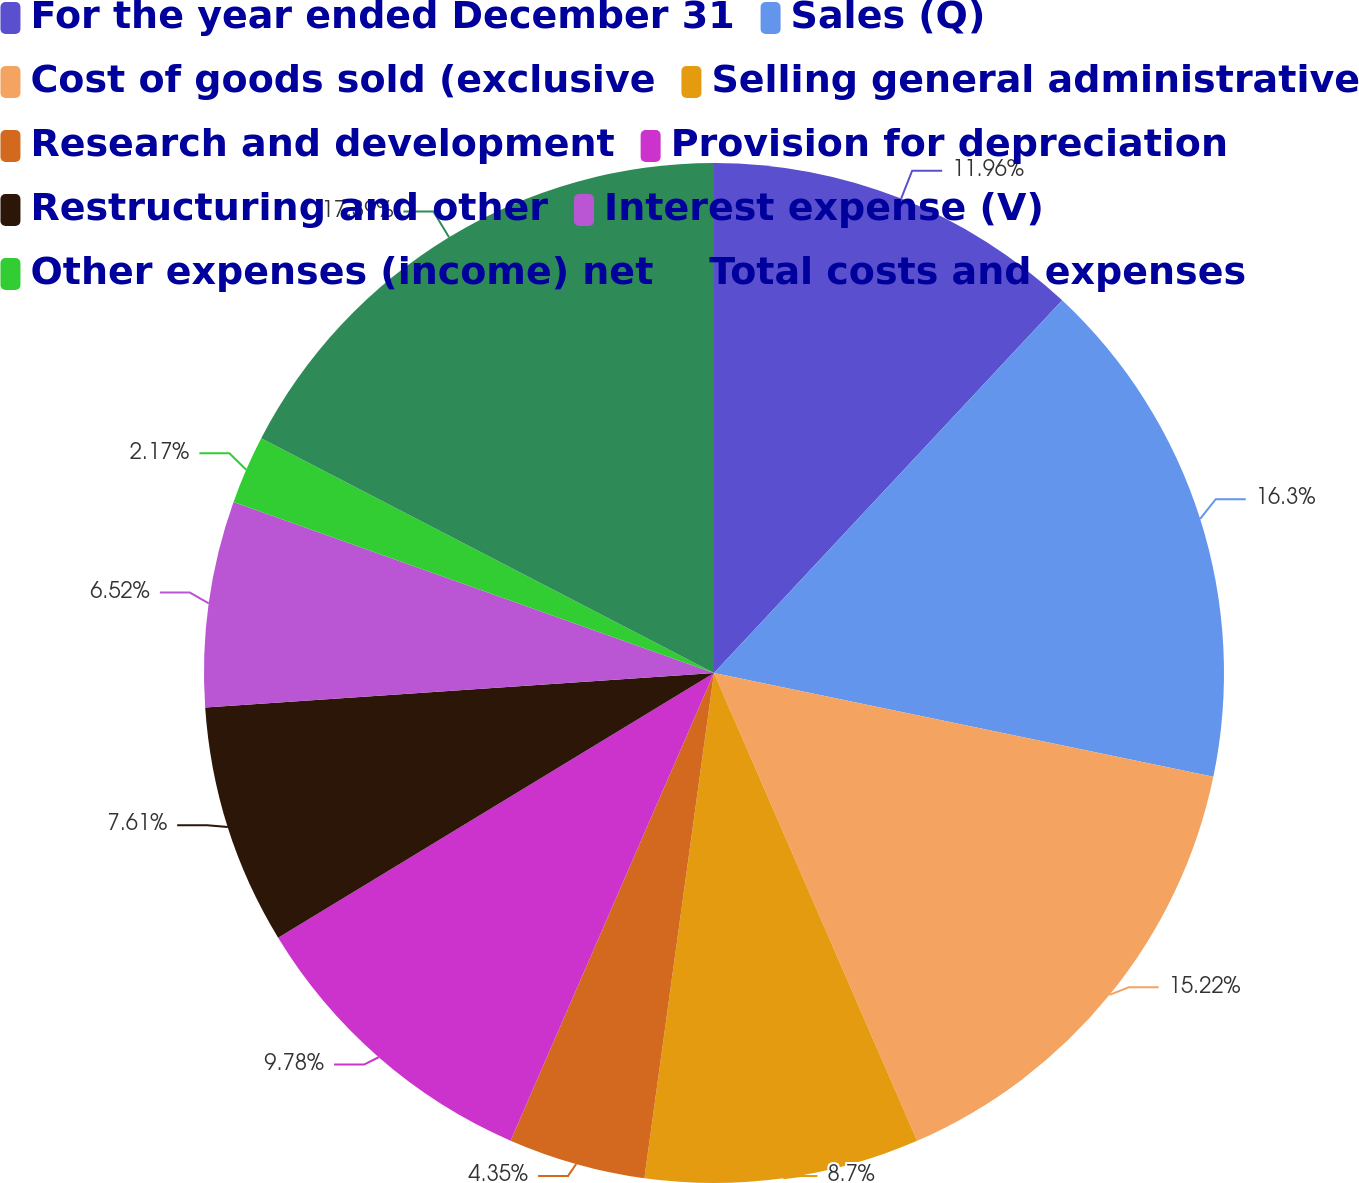Convert chart to OTSL. <chart><loc_0><loc_0><loc_500><loc_500><pie_chart><fcel>For the year ended December 31<fcel>Sales (Q)<fcel>Cost of goods sold (exclusive<fcel>Selling general administrative<fcel>Research and development<fcel>Provision for depreciation<fcel>Restructuring and other<fcel>Interest expense (V)<fcel>Other expenses (income) net<fcel>Total costs and expenses<nl><fcel>11.96%<fcel>16.3%<fcel>15.22%<fcel>8.7%<fcel>4.35%<fcel>9.78%<fcel>7.61%<fcel>6.52%<fcel>2.17%<fcel>17.39%<nl></chart> 